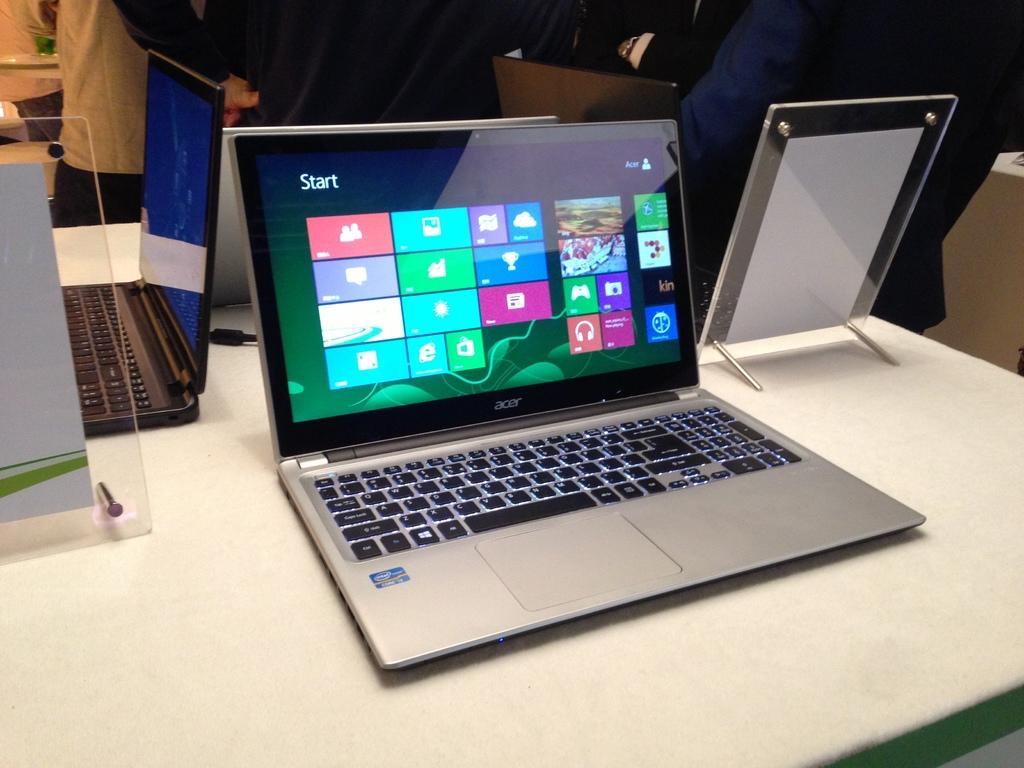What electronic devices are on the table in the image? There are laptops on a table in the image. What is the other item on the table besides the laptops? There is a glass board on the table. Can you describe the background of the image? There are persons and objects visible in the background of the image. What type of grape is being used as a paperweight on the glass board? There is no grape present on the glass board in the image. Is there a shelf visible in the image? No, there is no shelf visible in the image. 